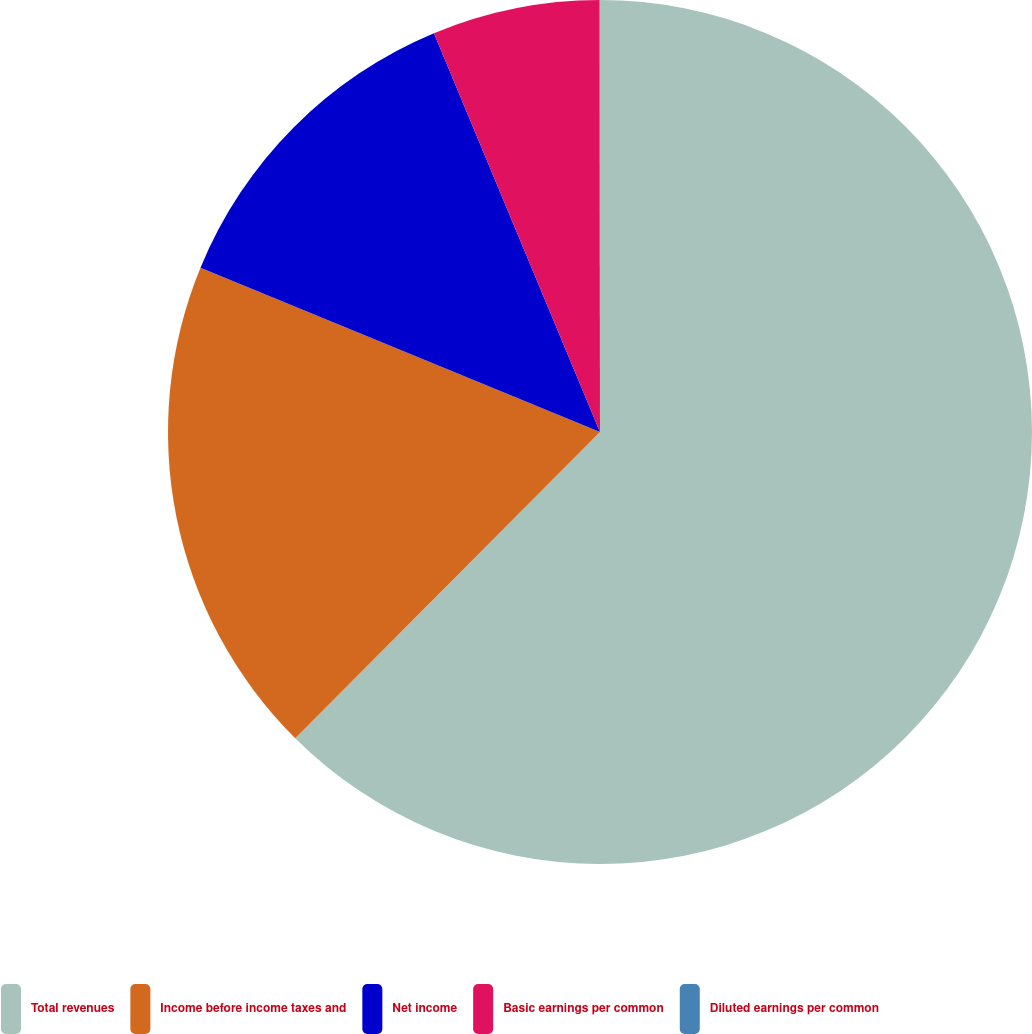<chart> <loc_0><loc_0><loc_500><loc_500><pie_chart><fcel>Total revenues<fcel>Income before income taxes and<fcel>Net income<fcel>Basic earnings per common<fcel>Diluted earnings per common<nl><fcel>62.47%<fcel>18.75%<fcel>12.51%<fcel>6.26%<fcel>0.02%<nl></chart> 